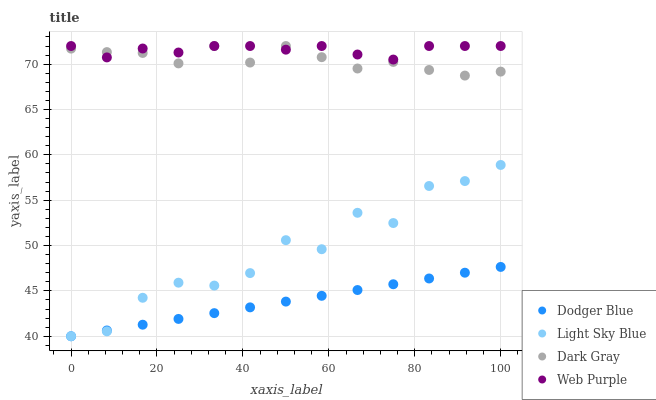Does Dodger Blue have the minimum area under the curve?
Answer yes or no. Yes. Does Web Purple have the maximum area under the curve?
Answer yes or no. Yes. Does Light Sky Blue have the minimum area under the curve?
Answer yes or no. No. Does Light Sky Blue have the maximum area under the curve?
Answer yes or no. No. Is Dodger Blue the smoothest?
Answer yes or no. Yes. Is Light Sky Blue the roughest?
Answer yes or no. Yes. Is Web Purple the smoothest?
Answer yes or no. No. Is Web Purple the roughest?
Answer yes or no. No. Does Light Sky Blue have the lowest value?
Answer yes or no. Yes. Does Web Purple have the lowest value?
Answer yes or no. No. Does Web Purple have the highest value?
Answer yes or no. Yes. Does Light Sky Blue have the highest value?
Answer yes or no. No. Is Dodger Blue less than Web Purple?
Answer yes or no. Yes. Is Dark Gray greater than Light Sky Blue?
Answer yes or no. Yes. Does Web Purple intersect Dark Gray?
Answer yes or no. Yes. Is Web Purple less than Dark Gray?
Answer yes or no. No. Is Web Purple greater than Dark Gray?
Answer yes or no. No. Does Dodger Blue intersect Web Purple?
Answer yes or no. No. 